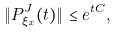<formula> <loc_0><loc_0><loc_500><loc_500>\| P _ { \xi _ { x } } ^ { J } ( t ) \| \leq e ^ { t C } ,</formula> 